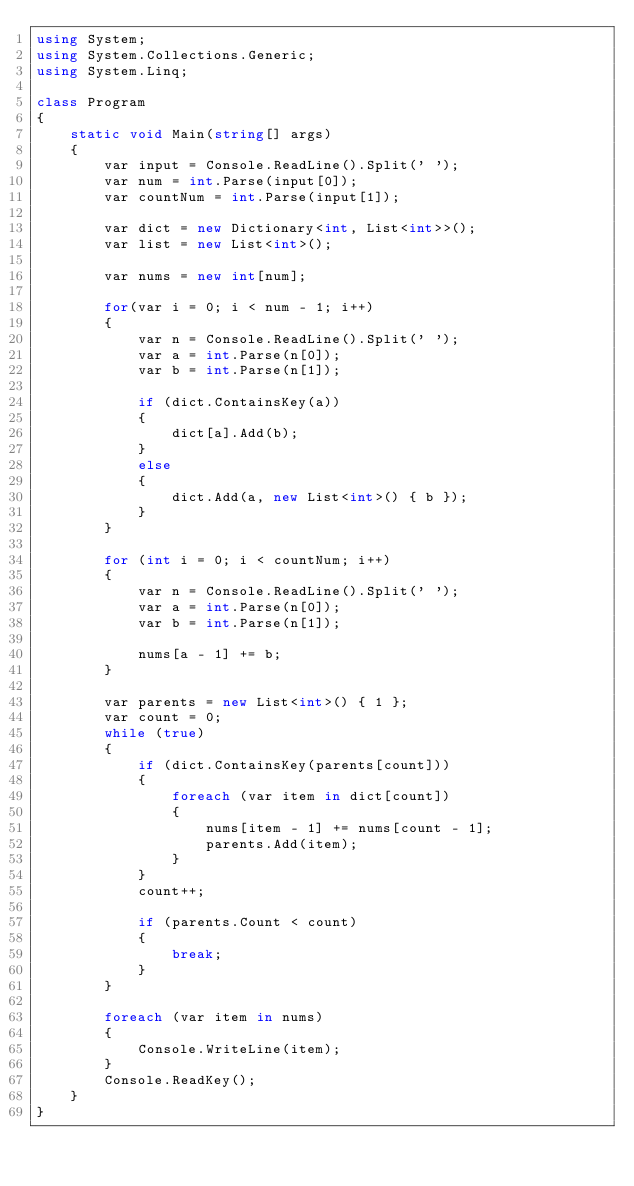Convert code to text. <code><loc_0><loc_0><loc_500><loc_500><_C#_>using System;
using System.Collections.Generic;
using System.Linq;

class Program
{
    static void Main(string[] args)
    {
        var input = Console.ReadLine().Split(' ');
        var num = int.Parse(input[0]);
        var countNum = int.Parse(input[1]);

        var dict = new Dictionary<int, List<int>>();
        var list = new List<int>();

        var nums = new int[num];

        for(var i = 0; i < num - 1; i++)
        {
            var n = Console.ReadLine().Split(' ');
            var a = int.Parse(n[0]);
            var b = int.Parse(n[1]);

            if (dict.ContainsKey(a))
            {
                dict[a].Add(b);
            }
            else
            {
                dict.Add(a, new List<int>() { b });
            }
        }

        for (int i = 0; i < countNum; i++)
        {
            var n = Console.ReadLine().Split(' ');
            var a = int.Parse(n[0]);
            var b = int.Parse(n[1]);

            nums[a - 1] += b;
        }

        var parents = new List<int>() { 1 };
        var count = 0;
        while (true)
        {
            if (dict.ContainsKey(parents[count]))
            {
                foreach (var item in dict[count])
                {
                    nums[item - 1] += nums[count - 1];
                    parents.Add(item);
                }                
            }
            count++;

            if (parents.Count < count)
            {
                break;
            }
        }

        foreach (var item in nums)
        {
            Console.WriteLine(item);
        }
        Console.ReadKey();
    }
}
</code> 